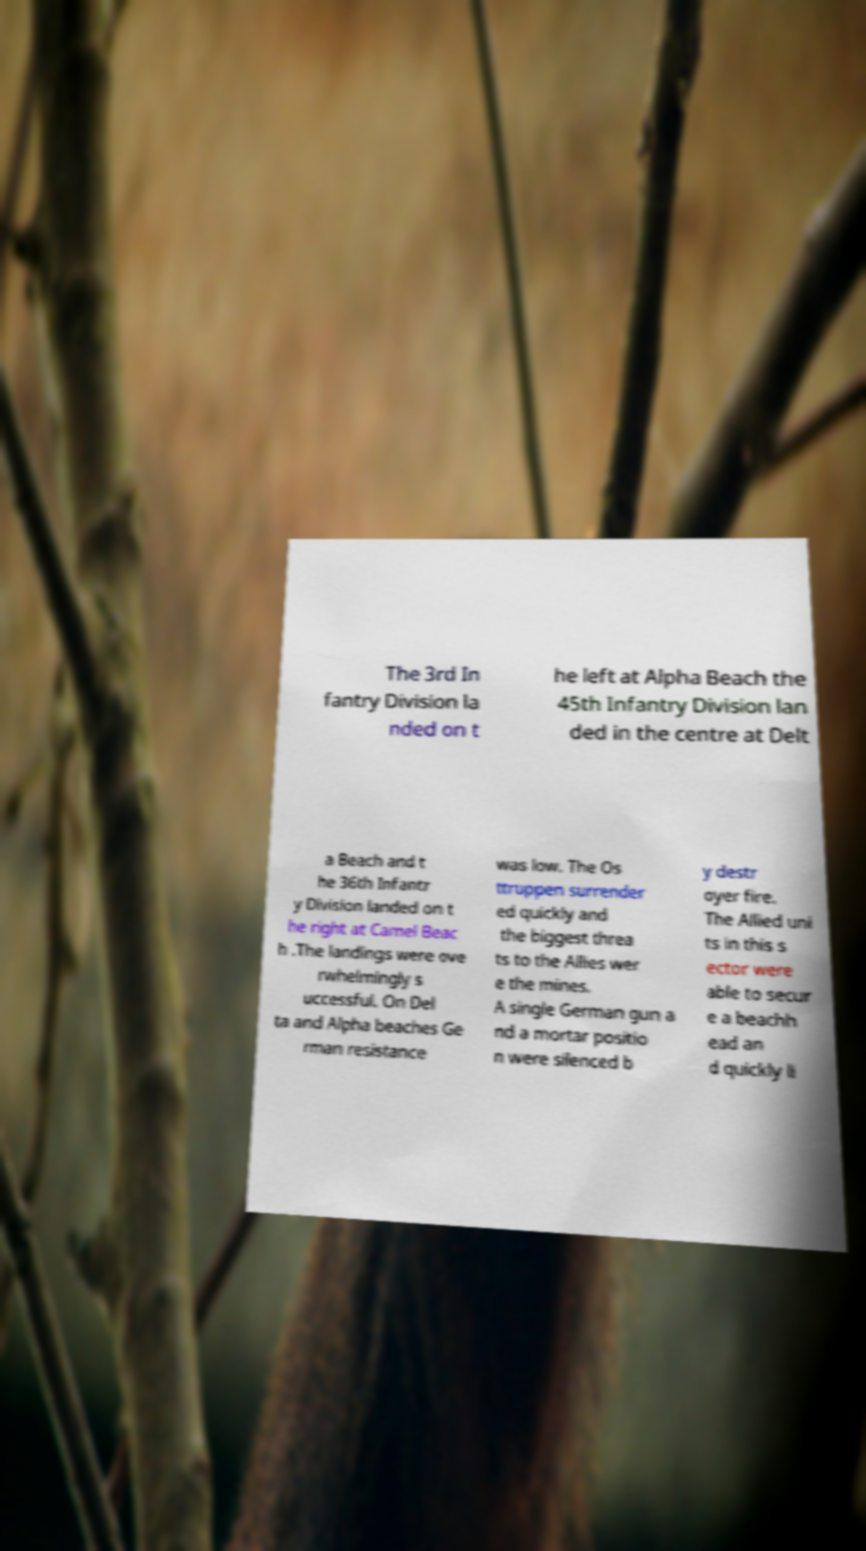Could you extract and type out the text from this image? The 3rd In fantry Division la nded on t he left at Alpha Beach the 45th Infantry Division lan ded in the centre at Delt a Beach and t he 36th Infantr y Division landed on t he right at Camel Beac h .The landings were ove rwhelmingly s uccessful. On Del ta and Alpha beaches Ge rman resistance was low. The Os ttruppen surrender ed quickly and the biggest threa ts to the Allies wer e the mines. A single German gun a nd a mortar positio n were silenced b y destr oyer fire. The Allied uni ts in this s ector were able to secur e a beachh ead an d quickly li 